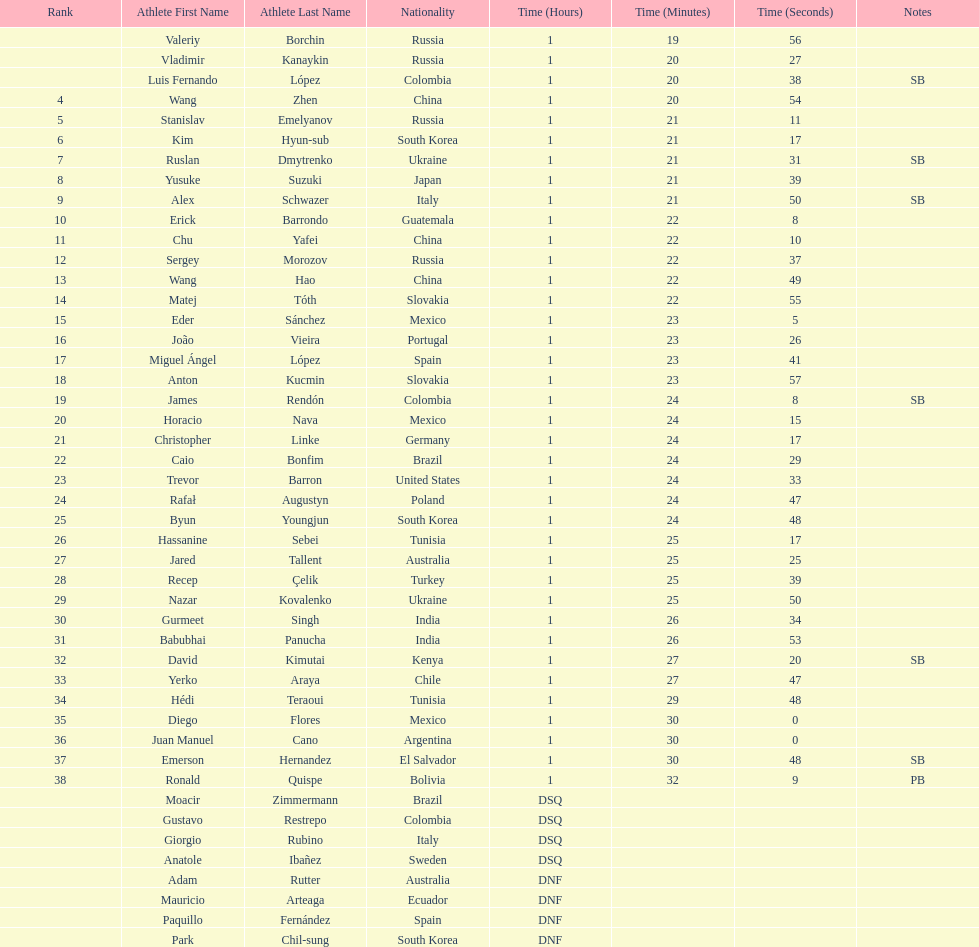What is the total count of athletes included in the rankings chart, including those classified as dsq & dnf? 46. 